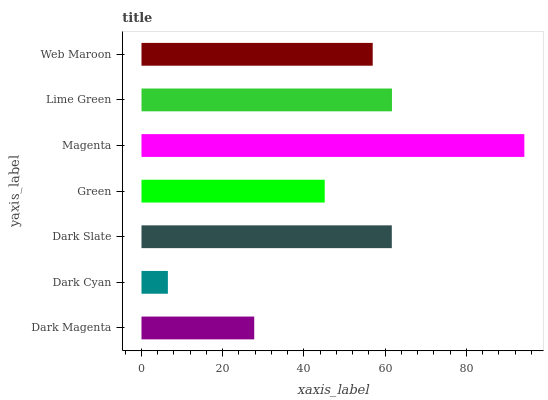Is Dark Cyan the minimum?
Answer yes or no. Yes. Is Magenta the maximum?
Answer yes or no. Yes. Is Dark Slate the minimum?
Answer yes or no. No. Is Dark Slate the maximum?
Answer yes or no. No. Is Dark Slate greater than Dark Cyan?
Answer yes or no. Yes. Is Dark Cyan less than Dark Slate?
Answer yes or no. Yes. Is Dark Cyan greater than Dark Slate?
Answer yes or no. No. Is Dark Slate less than Dark Cyan?
Answer yes or no. No. Is Web Maroon the high median?
Answer yes or no. Yes. Is Web Maroon the low median?
Answer yes or no. Yes. Is Dark Cyan the high median?
Answer yes or no. No. Is Green the low median?
Answer yes or no. No. 